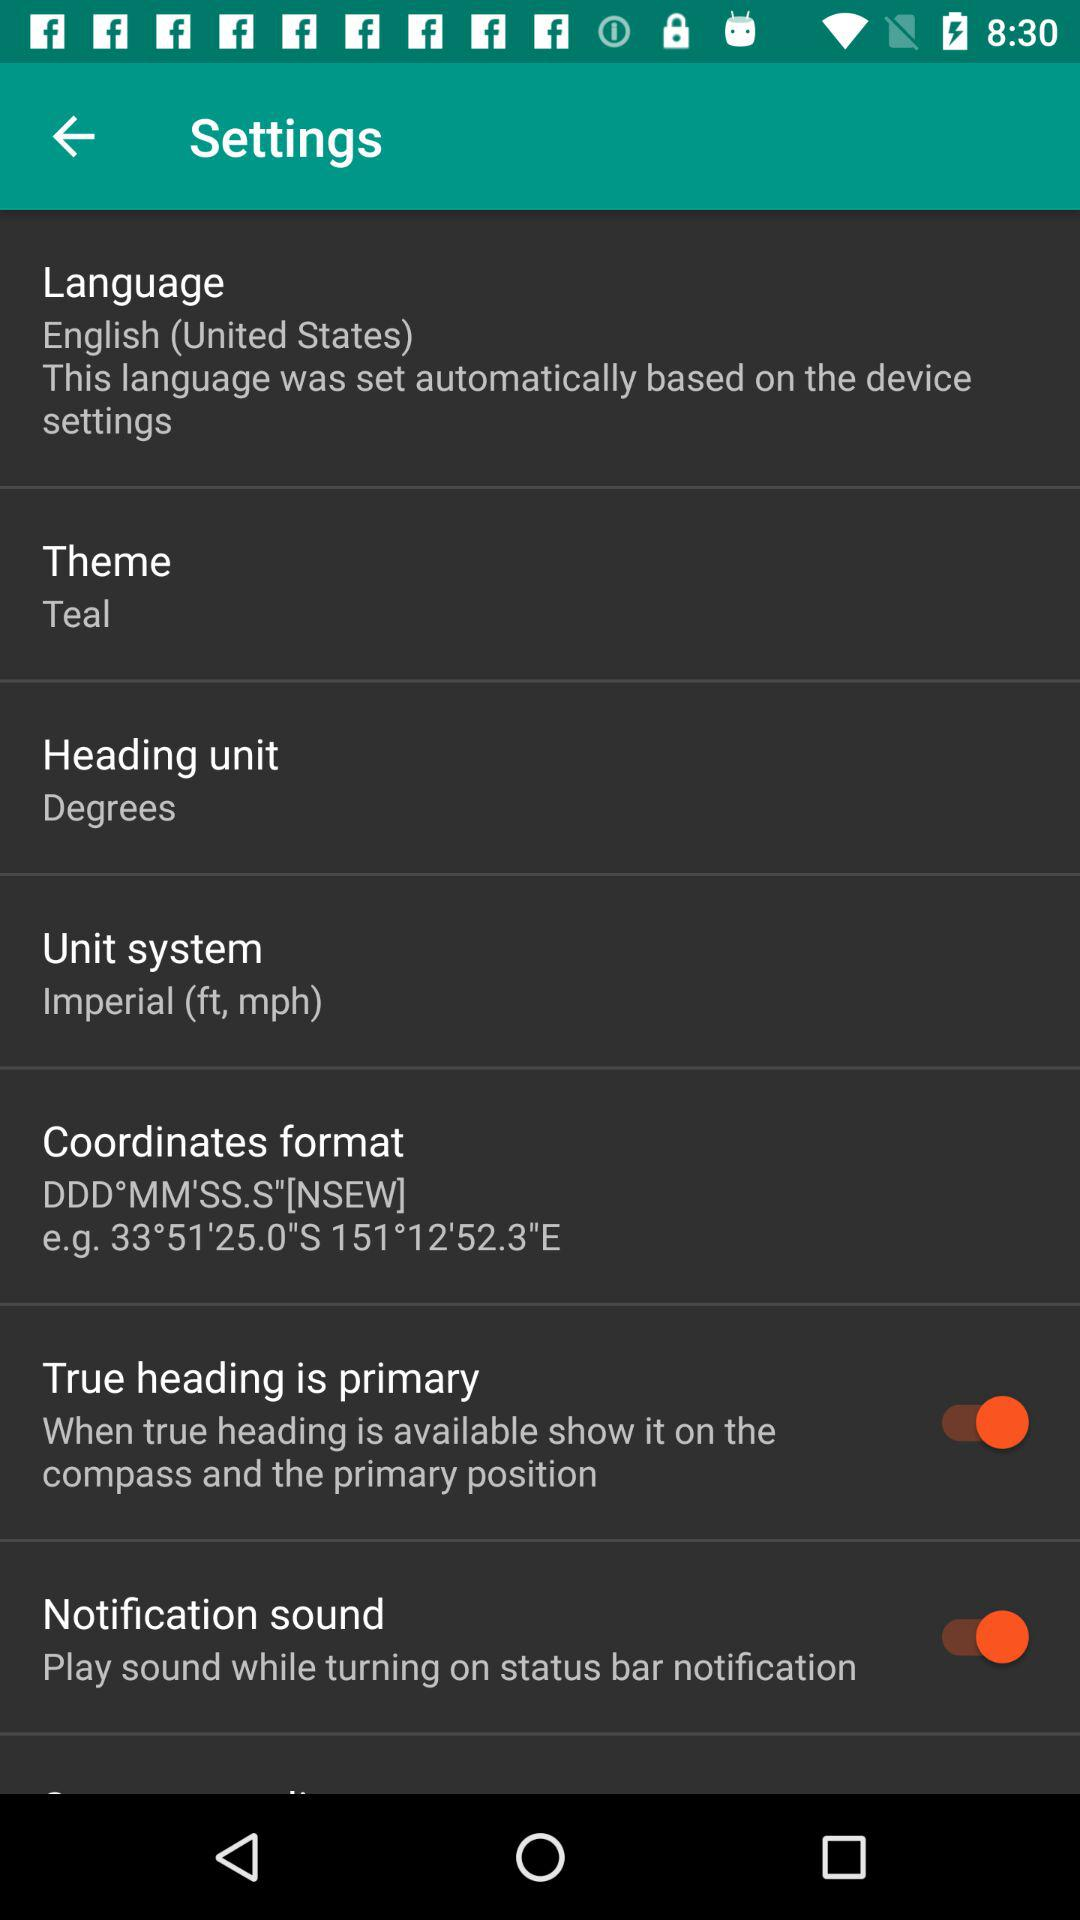What does the "Notification sound" setting do? The "Notification sound" setting plays sound while turning on status bar notification. 